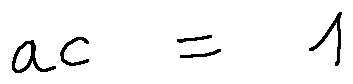<formula> <loc_0><loc_0><loc_500><loc_500>a c = 1</formula> 